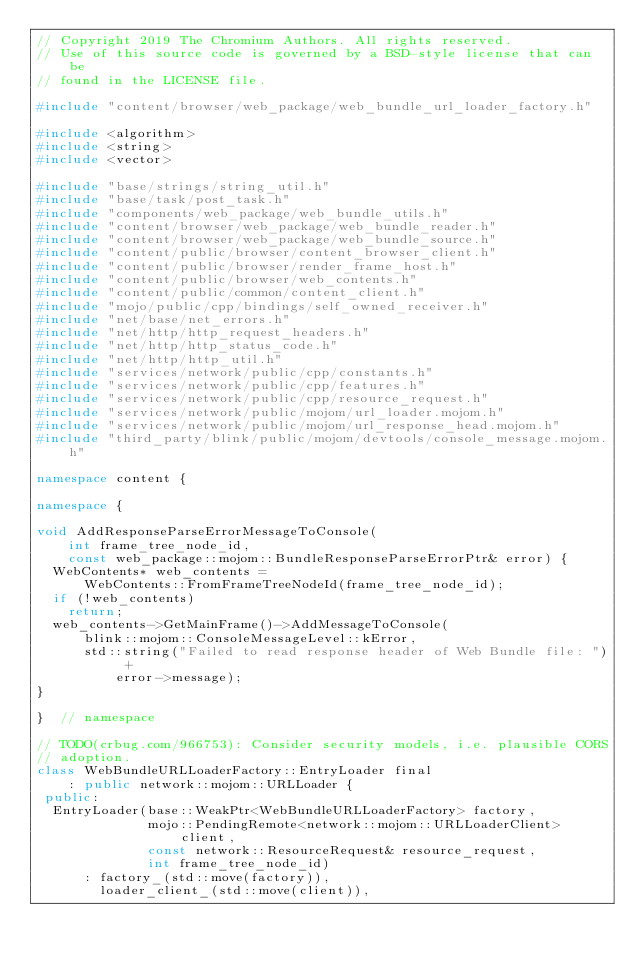<code> <loc_0><loc_0><loc_500><loc_500><_C++_>// Copyright 2019 The Chromium Authors. All rights reserved.
// Use of this source code is governed by a BSD-style license that can be
// found in the LICENSE file.

#include "content/browser/web_package/web_bundle_url_loader_factory.h"

#include <algorithm>
#include <string>
#include <vector>

#include "base/strings/string_util.h"
#include "base/task/post_task.h"
#include "components/web_package/web_bundle_utils.h"
#include "content/browser/web_package/web_bundle_reader.h"
#include "content/browser/web_package/web_bundle_source.h"
#include "content/public/browser/content_browser_client.h"
#include "content/public/browser/render_frame_host.h"
#include "content/public/browser/web_contents.h"
#include "content/public/common/content_client.h"
#include "mojo/public/cpp/bindings/self_owned_receiver.h"
#include "net/base/net_errors.h"
#include "net/http/http_request_headers.h"
#include "net/http/http_status_code.h"
#include "net/http/http_util.h"
#include "services/network/public/cpp/constants.h"
#include "services/network/public/cpp/features.h"
#include "services/network/public/cpp/resource_request.h"
#include "services/network/public/mojom/url_loader.mojom.h"
#include "services/network/public/mojom/url_response_head.mojom.h"
#include "third_party/blink/public/mojom/devtools/console_message.mojom.h"

namespace content {

namespace {

void AddResponseParseErrorMessageToConsole(
    int frame_tree_node_id,
    const web_package::mojom::BundleResponseParseErrorPtr& error) {
  WebContents* web_contents =
      WebContents::FromFrameTreeNodeId(frame_tree_node_id);
  if (!web_contents)
    return;
  web_contents->GetMainFrame()->AddMessageToConsole(
      blink::mojom::ConsoleMessageLevel::kError,
      std::string("Failed to read response header of Web Bundle file: ") +
          error->message);
}

}  // namespace

// TODO(crbug.com/966753): Consider security models, i.e. plausible CORS
// adoption.
class WebBundleURLLoaderFactory::EntryLoader final
    : public network::mojom::URLLoader {
 public:
  EntryLoader(base::WeakPtr<WebBundleURLLoaderFactory> factory,
              mojo::PendingRemote<network::mojom::URLLoaderClient> client,
              const network::ResourceRequest& resource_request,
              int frame_tree_node_id)
      : factory_(std::move(factory)),
        loader_client_(std::move(client)),</code> 